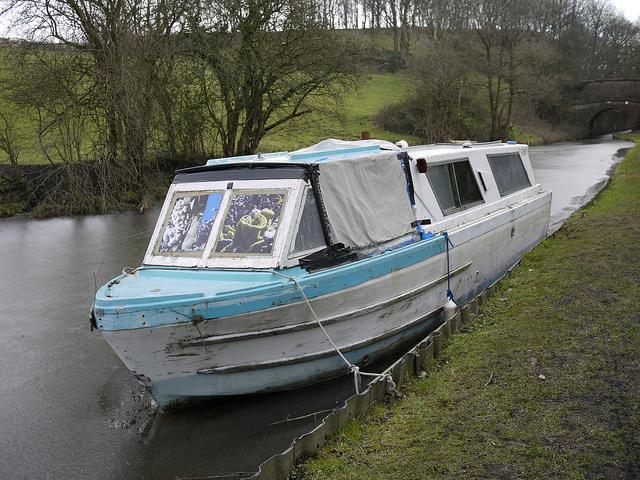How many windows can you see on the boat?
Give a very brief answer. 4. 